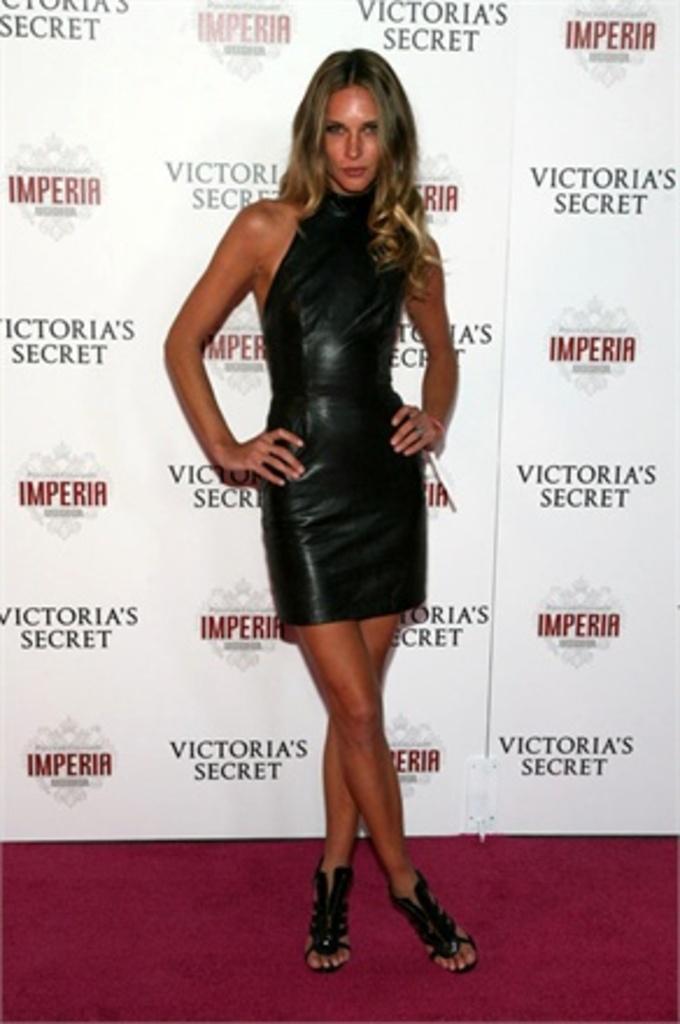Describe this image in one or two sentences. In this picture we can see a woman is standing, she wore a black color dress, in the background we can see logos and some text. 